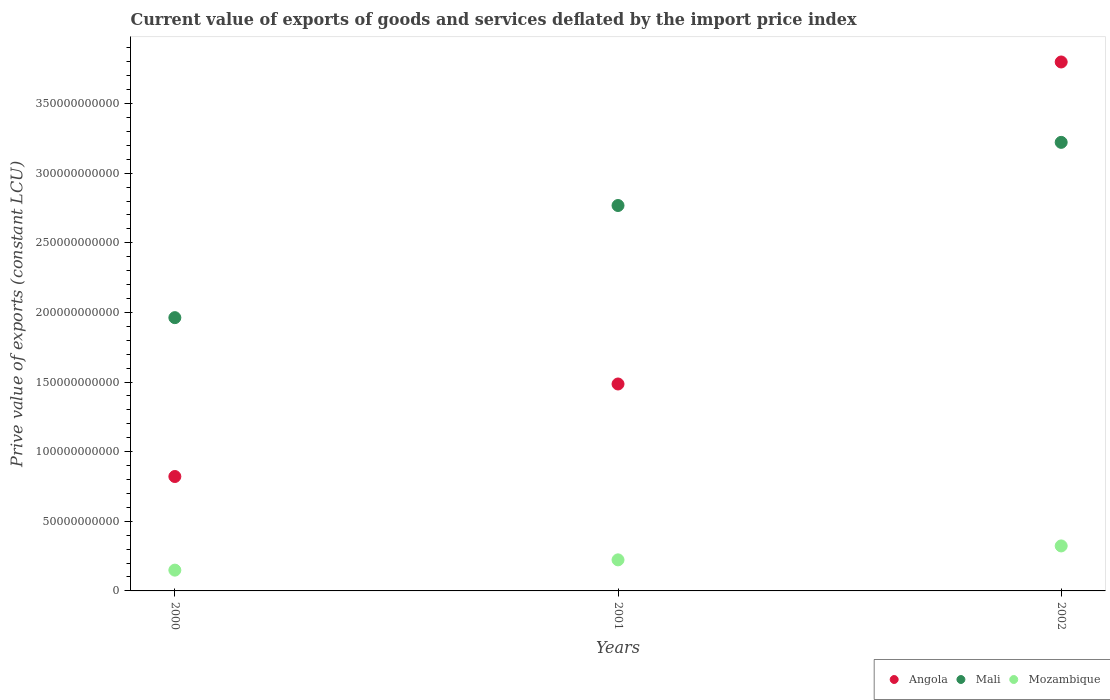How many different coloured dotlines are there?
Provide a short and direct response. 3. Is the number of dotlines equal to the number of legend labels?
Your answer should be very brief. Yes. What is the prive value of exports in Mali in 2000?
Your response must be concise. 1.96e+11. Across all years, what is the maximum prive value of exports in Mali?
Offer a terse response. 3.22e+11. Across all years, what is the minimum prive value of exports in Mozambique?
Keep it short and to the point. 1.49e+1. What is the total prive value of exports in Angola in the graph?
Your answer should be very brief. 6.11e+11. What is the difference between the prive value of exports in Angola in 2000 and that in 2002?
Ensure brevity in your answer.  -2.98e+11. What is the difference between the prive value of exports in Angola in 2002 and the prive value of exports in Mozambique in 2001?
Your response must be concise. 3.58e+11. What is the average prive value of exports in Mali per year?
Keep it short and to the point. 2.65e+11. In the year 2002, what is the difference between the prive value of exports in Mali and prive value of exports in Mozambique?
Give a very brief answer. 2.90e+11. In how many years, is the prive value of exports in Angola greater than 250000000000 LCU?
Give a very brief answer. 1. What is the ratio of the prive value of exports in Mali in 2000 to that in 2002?
Keep it short and to the point. 0.61. What is the difference between the highest and the second highest prive value of exports in Mozambique?
Offer a terse response. 1.00e+1. What is the difference between the highest and the lowest prive value of exports in Mozambique?
Ensure brevity in your answer.  1.74e+1. Is the prive value of exports in Angola strictly less than the prive value of exports in Mozambique over the years?
Offer a terse response. No. Are the values on the major ticks of Y-axis written in scientific E-notation?
Give a very brief answer. No. Does the graph contain grids?
Give a very brief answer. No. How many legend labels are there?
Keep it short and to the point. 3. How are the legend labels stacked?
Make the answer very short. Horizontal. What is the title of the graph?
Provide a succinct answer. Current value of exports of goods and services deflated by the import price index. What is the label or title of the X-axis?
Your answer should be compact. Years. What is the label or title of the Y-axis?
Offer a very short reply. Prive value of exports (constant LCU). What is the Prive value of exports (constant LCU) in Angola in 2000?
Keep it short and to the point. 8.22e+1. What is the Prive value of exports (constant LCU) of Mali in 2000?
Give a very brief answer. 1.96e+11. What is the Prive value of exports (constant LCU) in Mozambique in 2000?
Your response must be concise. 1.49e+1. What is the Prive value of exports (constant LCU) of Angola in 2001?
Your response must be concise. 1.49e+11. What is the Prive value of exports (constant LCU) of Mali in 2001?
Offer a very short reply. 2.77e+11. What is the Prive value of exports (constant LCU) of Mozambique in 2001?
Ensure brevity in your answer.  2.23e+1. What is the Prive value of exports (constant LCU) in Angola in 2002?
Offer a terse response. 3.80e+11. What is the Prive value of exports (constant LCU) of Mali in 2002?
Keep it short and to the point. 3.22e+11. What is the Prive value of exports (constant LCU) in Mozambique in 2002?
Your answer should be very brief. 3.23e+1. Across all years, what is the maximum Prive value of exports (constant LCU) in Angola?
Keep it short and to the point. 3.80e+11. Across all years, what is the maximum Prive value of exports (constant LCU) in Mali?
Make the answer very short. 3.22e+11. Across all years, what is the maximum Prive value of exports (constant LCU) of Mozambique?
Keep it short and to the point. 3.23e+1. Across all years, what is the minimum Prive value of exports (constant LCU) in Angola?
Make the answer very short. 8.22e+1. Across all years, what is the minimum Prive value of exports (constant LCU) of Mali?
Offer a very short reply. 1.96e+11. Across all years, what is the minimum Prive value of exports (constant LCU) of Mozambique?
Your answer should be very brief. 1.49e+1. What is the total Prive value of exports (constant LCU) in Angola in the graph?
Ensure brevity in your answer.  6.11e+11. What is the total Prive value of exports (constant LCU) of Mali in the graph?
Give a very brief answer. 7.95e+11. What is the total Prive value of exports (constant LCU) in Mozambique in the graph?
Give a very brief answer. 6.95e+1. What is the difference between the Prive value of exports (constant LCU) in Angola in 2000 and that in 2001?
Your answer should be compact. -6.64e+1. What is the difference between the Prive value of exports (constant LCU) of Mali in 2000 and that in 2001?
Ensure brevity in your answer.  -8.05e+1. What is the difference between the Prive value of exports (constant LCU) in Mozambique in 2000 and that in 2001?
Offer a very short reply. -7.37e+09. What is the difference between the Prive value of exports (constant LCU) of Angola in 2000 and that in 2002?
Your response must be concise. -2.98e+11. What is the difference between the Prive value of exports (constant LCU) in Mali in 2000 and that in 2002?
Make the answer very short. -1.26e+11. What is the difference between the Prive value of exports (constant LCU) in Mozambique in 2000 and that in 2002?
Provide a succinct answer. -1.74e+1. What is the difference between the Prive value of exports (constant LCU) of Angola in 2001 and that in 2002?
Provide a succinct answer. -2.31e+11. What is the difference between the Prive value of exports (constant LCU) of Mali in 2001 and that in 2002?
Offer a very short reply. -4.53e+1. What is the difference between the Prive value of exports (constant LCU) in Mozambique in 2001 and that in 2002?
Offer a terse response. -1.00e+1. What is the difference between the Prive value of exports (constant LCU) in Angola in 2000 and the Prive value of exports (constant LCU) in Mali in 2001?
Provide a succinct answer. -1.95e+11. What is the difference between the Prive value of exports (constant LCU) of Angola in 2000 and the Prive value of exports (constant LCU) of Mozambique in 2001?
Your response must be concise. 5.99e+1. What is the difference between the Prive value of exports (constant LCU) of Mali in 2000 and the Prive value of exports (constant LCU) of Mozambique in 2001?
Keep it short and to the point. 1.74e+11. What is the difference between the Prive value of exports (constant LCU) of Angola in 2000 and the Prive value of exports (constant LCU) of Mali in 2002?
Make the answer very short. -2.40e+11. What is the difference between the Prive value of exports (constant LCU) of Angola in 2000 and the Prive value of exports (constant LCU) of Mozambique in 2002?
Keep it short and to the point. 4.98e+1. What is the difference between the Prive value of exports (constant LCU) in Mali in 2000 and the Prive value of exports (constant LCU) in Mozambique in 2002?
Keep it short and to the point. 1.64e+11. What is the difference between the Prive value of exports (constant LCU) in Angola in 2001 and the Prive value of exports (constant LCU) in Mali in 2002?
Provide a short and direct response. -1.74e+11. What is the difference between the Prive value of exports (constant LCU) of Angola in 2001 and the Prive value of exports (constant LCU) of Mozambique in 2002?
Your answer should be compact. 1.16e+11. What is the difference between the Prive value of exports (constant LCU) of Mali in 2001 and the Prive value of exports (constant LCU) of Mozambique in 2002?
Keep it short and to the point. 2.44e+11. What is the average Prive value of exports (constant LCU) in Angola per year?
Make the answer very short. 2.04e+11. What is the average Prive value of exports (constant LCU) in Mali per year?
Your answer should be very brief. 2.65e+11. What is the average Prive value of exports (constant LCU) in Mozambique per year?
Give a very brief answer. 2.32e+1. In the year 2000, what is the difference between the Prive value of exports (constant LCU) in Angola and Prive value of exports (constant LCU) in Mali?
Keep it short and to the point. -1.14e+11. In the year 2000, what is the difference between the Prive value of exports (constant LCU) in Angola and Prive value of exports (constant LCU) in Mozambique?
Your answer should be compact. 6.72e+1. In the year 2000, what is the difference between the Prive value of exports (constant LCU) of Mali and Prive value of exports (constant LCU) of Mozambique?
Your response must be concise. 1.81e+11. In the year 2001, what is the difference between the Prive value of exports (constant LCU) in Angola and Prive value of exports (constant LCU) in Mali?
Provide a short and direct response. -1.28e+11. In the year 2001, what is the difference between the Prive value of exports (constant LCU) of Angola and Prive value of exports (constant LCU) of Mozambique?
Make the answer very short. 1.26e+11. In the year 2001, what is the difference between the Prive value of exports (constant LCU) of Mali and Prive value of exports (constant LCU) of Mozambique?
Your answer should be very brief. 2.54e+11. In the year 2002, what is the difference between the Prive value of exports (constant LCU) of Angola and Prive value of exports (constant LCU) of Mali?
Your response must be concise. 5.77e+1. In the year 2002, what is the difference between the Prive value of exports (constant LCU) in Angola and Prive value of exports (constant LCU) in Mozambique?
Offer a terse response. 3.48e+11. In the year 2002, what is the difference between the Prive value of exports (constant LCU) of Mali and Prive value of exports (constant LCU) of Mozambique?
Your response must be concise. 2.90e+11. What is the ratio of the Prive value of exports (constant LCU) in Angola in 2000 to that in 2001?
Make the answer very short. 0.55. What is the ratio of the Prive value of exports (constant LCU) in Mali in 2000 to that in 2001?
Offer a very short reply. 0.71. What is the ratio of the Prive value of exports (constant LCU) of Mozambique in 2000 to that in 2001?
Make the answer very short. 0.67. What is the ratio of the Prive value of exports (constant LCU) of Angola in 2000 to that in 2002?
Keep it short and to the point. 0.22. What is the ratio of the Prive value of exports (constant LCU) of Mali in 2000 to that in 2002?
Give a very brief answer. 0.61. What is the ratio of the Prive value of exports (constant LCU) of Mozambique in 2000 to that in 2002?
Offer a terse response. 0.46. What is the ratio of the Prive value of exports (constant LCU) in Angola in 2001 to that in 2002?
Give a very brief answer. 0.39. What is the ratio of the Prive value of exports (constant LCU) in Mali in 2001 to that in 2002?
Provide a short and direct response. 0.86. What is the ratio of the Prive value of exports (constant LCU) in Mozambique in 2001 to that in 2002?
Ensure brevity in your answer.  0.69. What is the difference between the highest and the second highest Prive value of exports (constant LCU) in Angola?
Give a very brief answer. 2.31e+11. What is the difference between the highest and the second highest Prive value of exports (constant LCU) in Mali?
Your answer should be very brief. 4.53e+1. What is the difference between the highest and the second highest Prive value of exports (constant LCU) of Mozambique?
Ensure brevity in your answer.  1.00e+1. What is the difference between the highest and the lowest Prive value of exports (constant LCU) of Angola?
Give a very brief answer. 2.98e+11. What is the difference between the highest and the lowest Prive value of exports (constant LCU) of Mali?
Your answer should be very brief. 1.26e+11. What is the difference between the highest and the lowest Prive value of exports (constant LCU) of Mozambique?
Provide a succinct answer. 1.74e+1. 